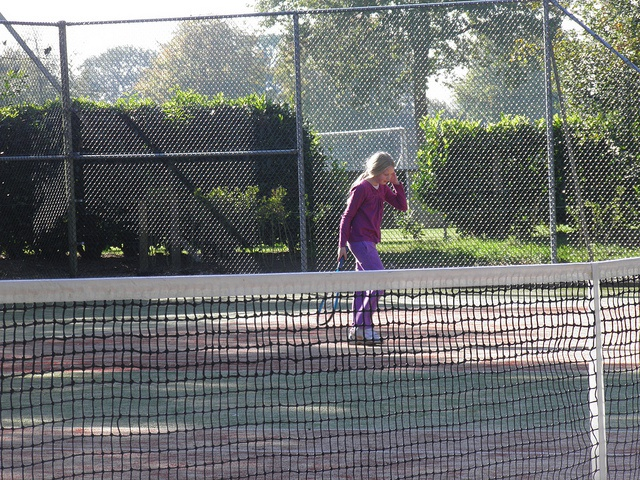Describe the objects in this image and their specific colors. I can see people in white, purple, gray, and black tones, tennis racket in white, lightgray, black, gray, and darkgray tones, bird in white, gray, and darkgray tones, and sports ball in white and gray tones in this image. 